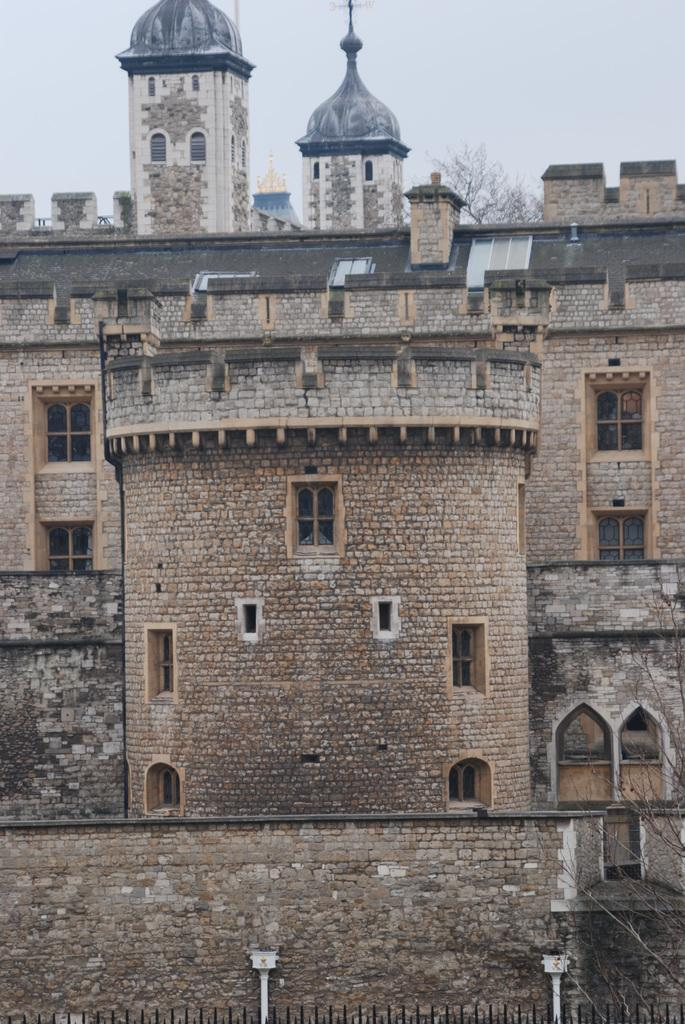What type of structures are visible in the image? There are buildings in the image. What material are the buildings made of? The buildings are made up of stone bricks. What is the condition of the sky in the image? The sky is clear in the image. What advice does the truck in the image give to the buildings? There is no truck present in the image, so it cannot provide any advice to the buildings. 